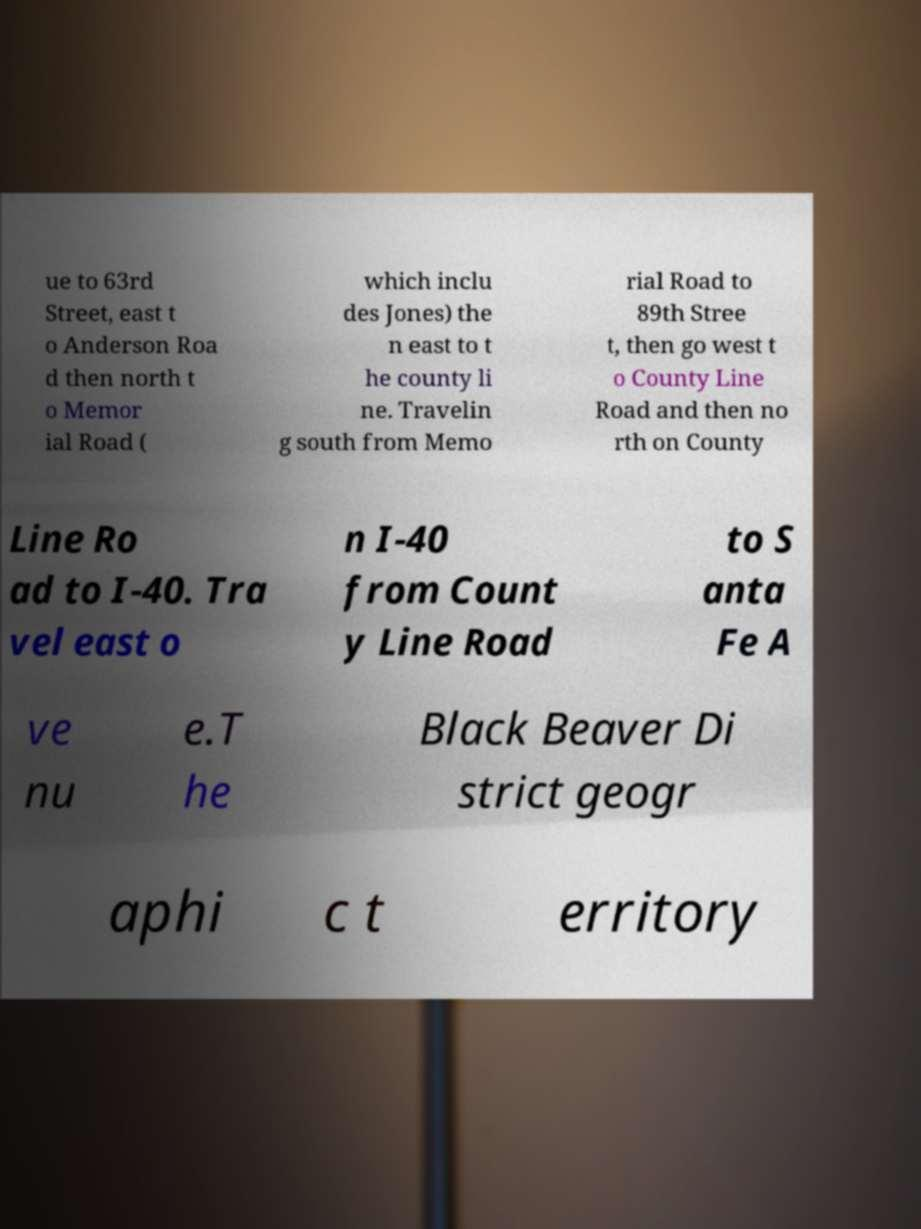What messages or text are displayed in this image? I need them in a readable, typed format. ue to 63rd Street, east t o Anderson Roa d then north t o Memor ial Road ( which inclu des Jones) the n east to t he county li ne. Travelin g south from Memo rial Road to 89th Stree t, then go west t o County Line Road and then no rth on County Line Ro ad to I-40. Tra vel east o n I-40 from Count y Line Road to S anta Fe A ve nu e.T he Black Beaver Di strict geogr aphi c t erritory 